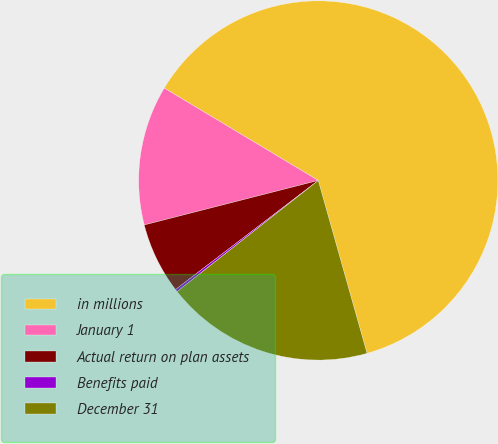Convert chart. <chart><loc_0><loc_0><loc_500><loc_500><pie_chart><fcel>in millions<fcel>January 1<fcel>Actual return on plan assets<fcel>Benefits paid<fcel>December 31<nl><fcel>62.02%<fcel>12.58%<fcel>6.4%<fcel>0.23%<fcel>18.76%<nl></chart> 